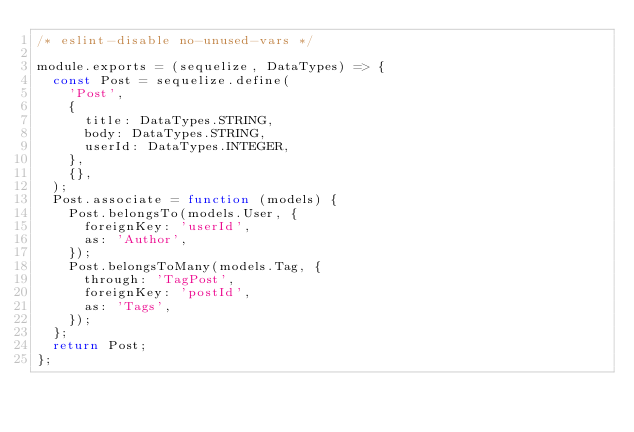<code> <loc_0><loc_0><loc_500><loc_500><_JavaScript_>/* eslint-disable no-unused-vars */

module.exports = (sequelize, DataTypes) => {
  const Post = sequelize.define(
    'Post',
    {
      title: DataTypes.STRING,
      body: DataTypes.STRING,
      userId: DataTypes.INTEGER,
    },
    {},
  );
  Post.associate = function (models) {
    Post.belongsTo(models.User, {
      foreignKey: 'userId',
      as: 'Author',
    });
    Post.belongsToMany(models.Tag, {
      through: 'TagPost',
      foreignKey: 'postId',
      as: 'Tags',
    });
  };
  return Post;
};
</code> 